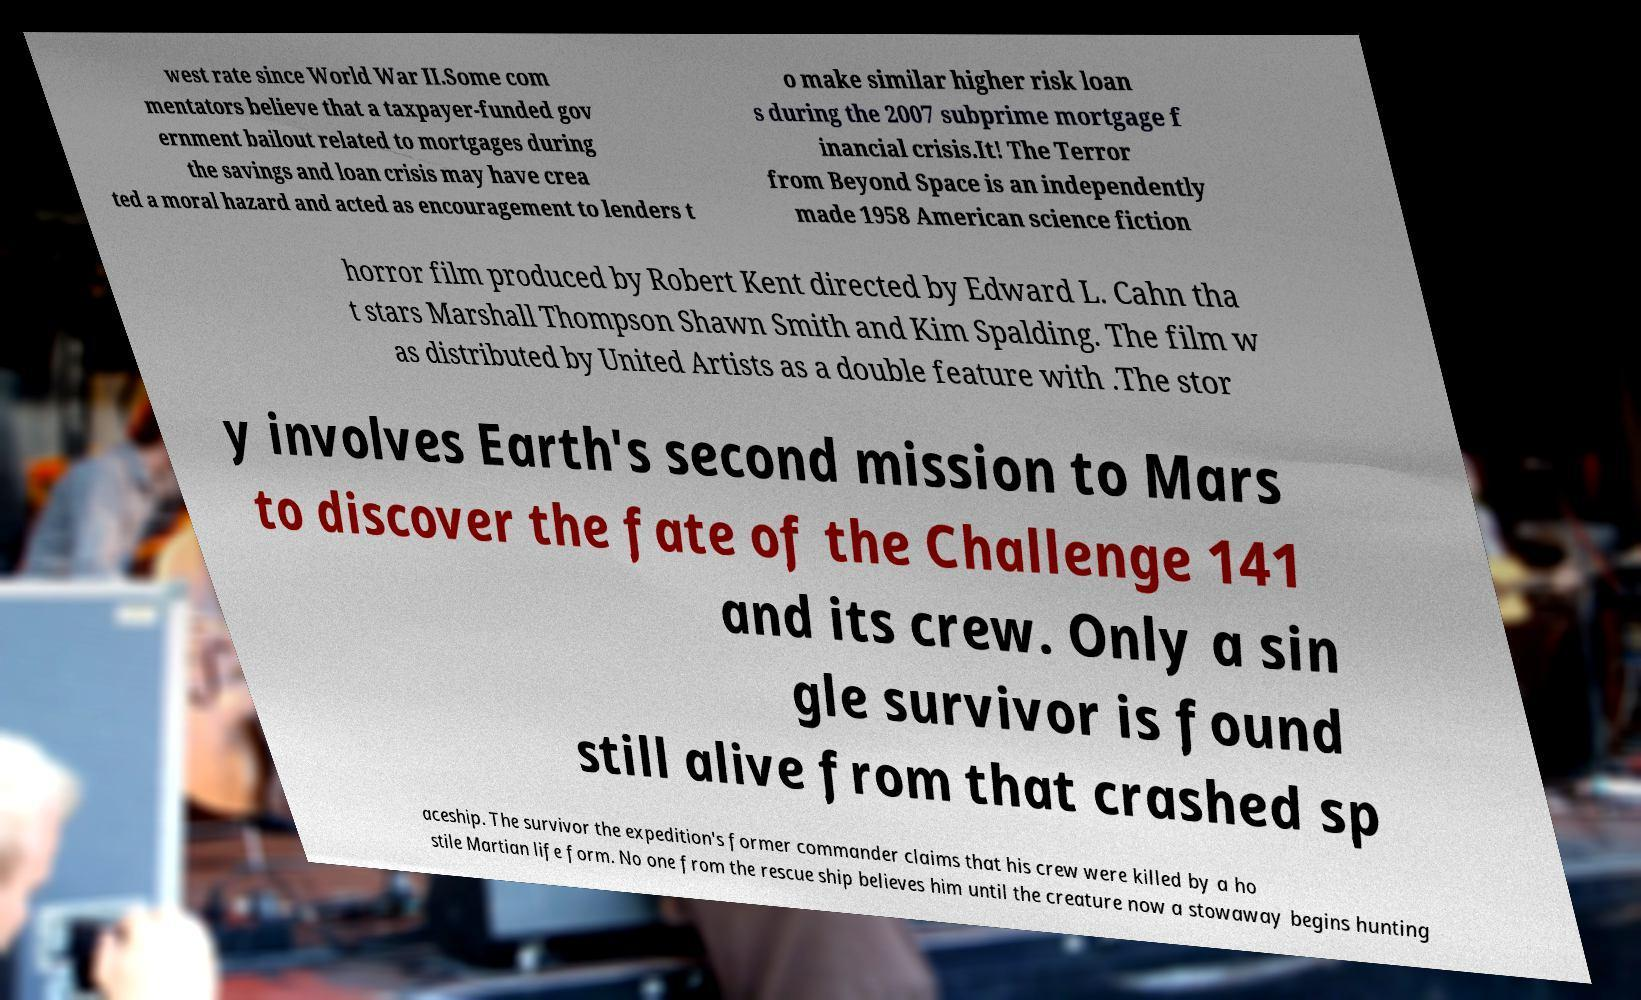I need the written content from this picture converted into text. Can you do that? west rate since World War II.Some com mentators believe that a taxpayer-funded gov ernment bailout related to mortgages during the savings and loan crisis may have crea ted a moral hazard and acted as encouragement to lenders t o make similar higher risk loan s during the 2007 subprime mortgage f inancial crisis.It! The Terror from Beyond Space is an independently made 1958 American science fiction horror film produced by Robert Kent directed by Edward L. Cahn tha t stars Marshall Thompson Shawn Smith and Kim Spalding. The film w as distributed by United Artists as a double feature with .The stor y involves Earth's second mission to Mars to discover the fate of the Challenge 141 and its crew. Only a sin gle survivor is found still alive from that crashed sp aceship. The survivor the expedition's former commander claims that his crew were killed by a ho stile Martian life form. No one from the rescue ship believes him until the creature now a stowaway begins hunting 